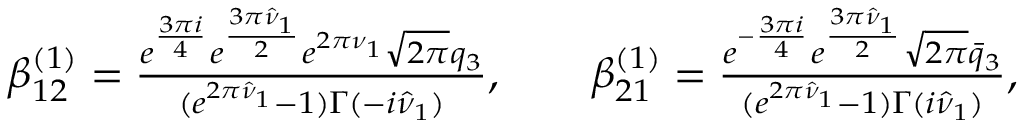<formula> <loc_0><loc_0><loc_500><loc_500>\begin{array} { r l } & { \beta _ { 1 2 } ^ { ( 1 ) } = \frac { e ^ { \frac { 3 \pi i } { 4 } } e ^ { \frac { 3 \pi \hat { \nu } _ { 1 } } { 2 } } e ^ { 2 \pi \nu _ { 1 } } \sqrt { 2 \pi } q _ { 3 } } { ( e ^ { 2 \pi \hat { \nu } _ { 1 } } - 1 ) \Gamma ( - i \hat { \nu } _ { 1 } ) } , \quad \beta _ { 2 1 } ^ { ( 1 ) } = \frac { e ^ { - \frac { 3 \pi i } { 4 } } e ^ { \frac { 3 \pi \hat { \nu } _ { 1 } } { 2 } } \sqrt { 2 \pi } \bar { q } _ { 3 } } { ( e ^ { 2 \pi \hat { \nu } _ { 1 } } - 1 ) \Gamma ( i \hat { \nu } _ { 1 } ) } , } \end{array}</formula> 